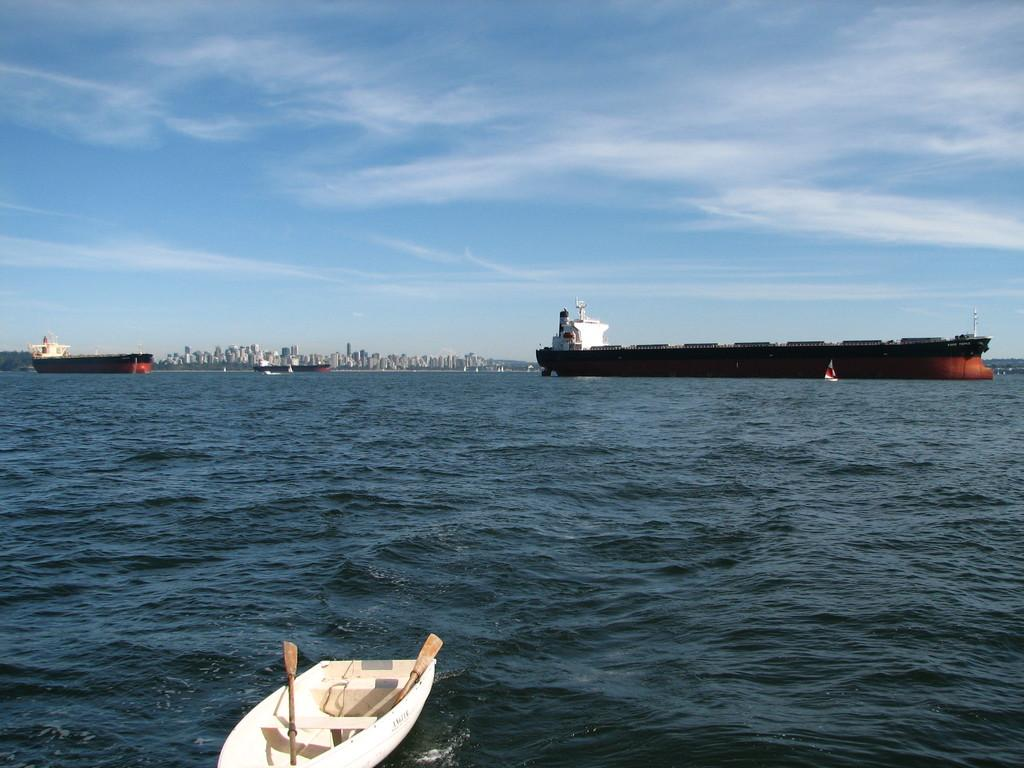What is in the water in the image? There is a boat in the water in the image. What can be seen in the water besides the boat? The water is visible in the image, but there are no other objects or features mentioned in the facts. What type of structures are present in the image? There are many buildings in the image. What is the condition of the sky in the image? The sky is cloudy in the image. How many tickets are visible in the image? There is no mention of tickets in the provided facts, so it cannot be determined if any are present in the image. 